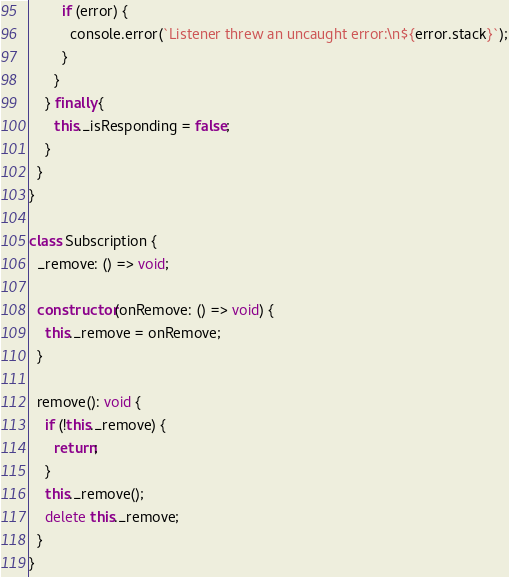<code> <loc_0><loc_0><loc_500><loc_500><_TypeScript_>        if (error) {
          console.error(`Listener threw an uncaught error:\n${error.stack}`);
        }
      }
    } finally {
      this._isResponding = false;
    }
  }
}

class Subscription {
  _remove: () => void;

  constructor(onRemove: () => void) {
    this._remove = onRemove;
  }

  remove(): void {
    if (!this._remove) {
      return;
    }
    this._remove();
    delete this._remove;
  }
}
</code> 